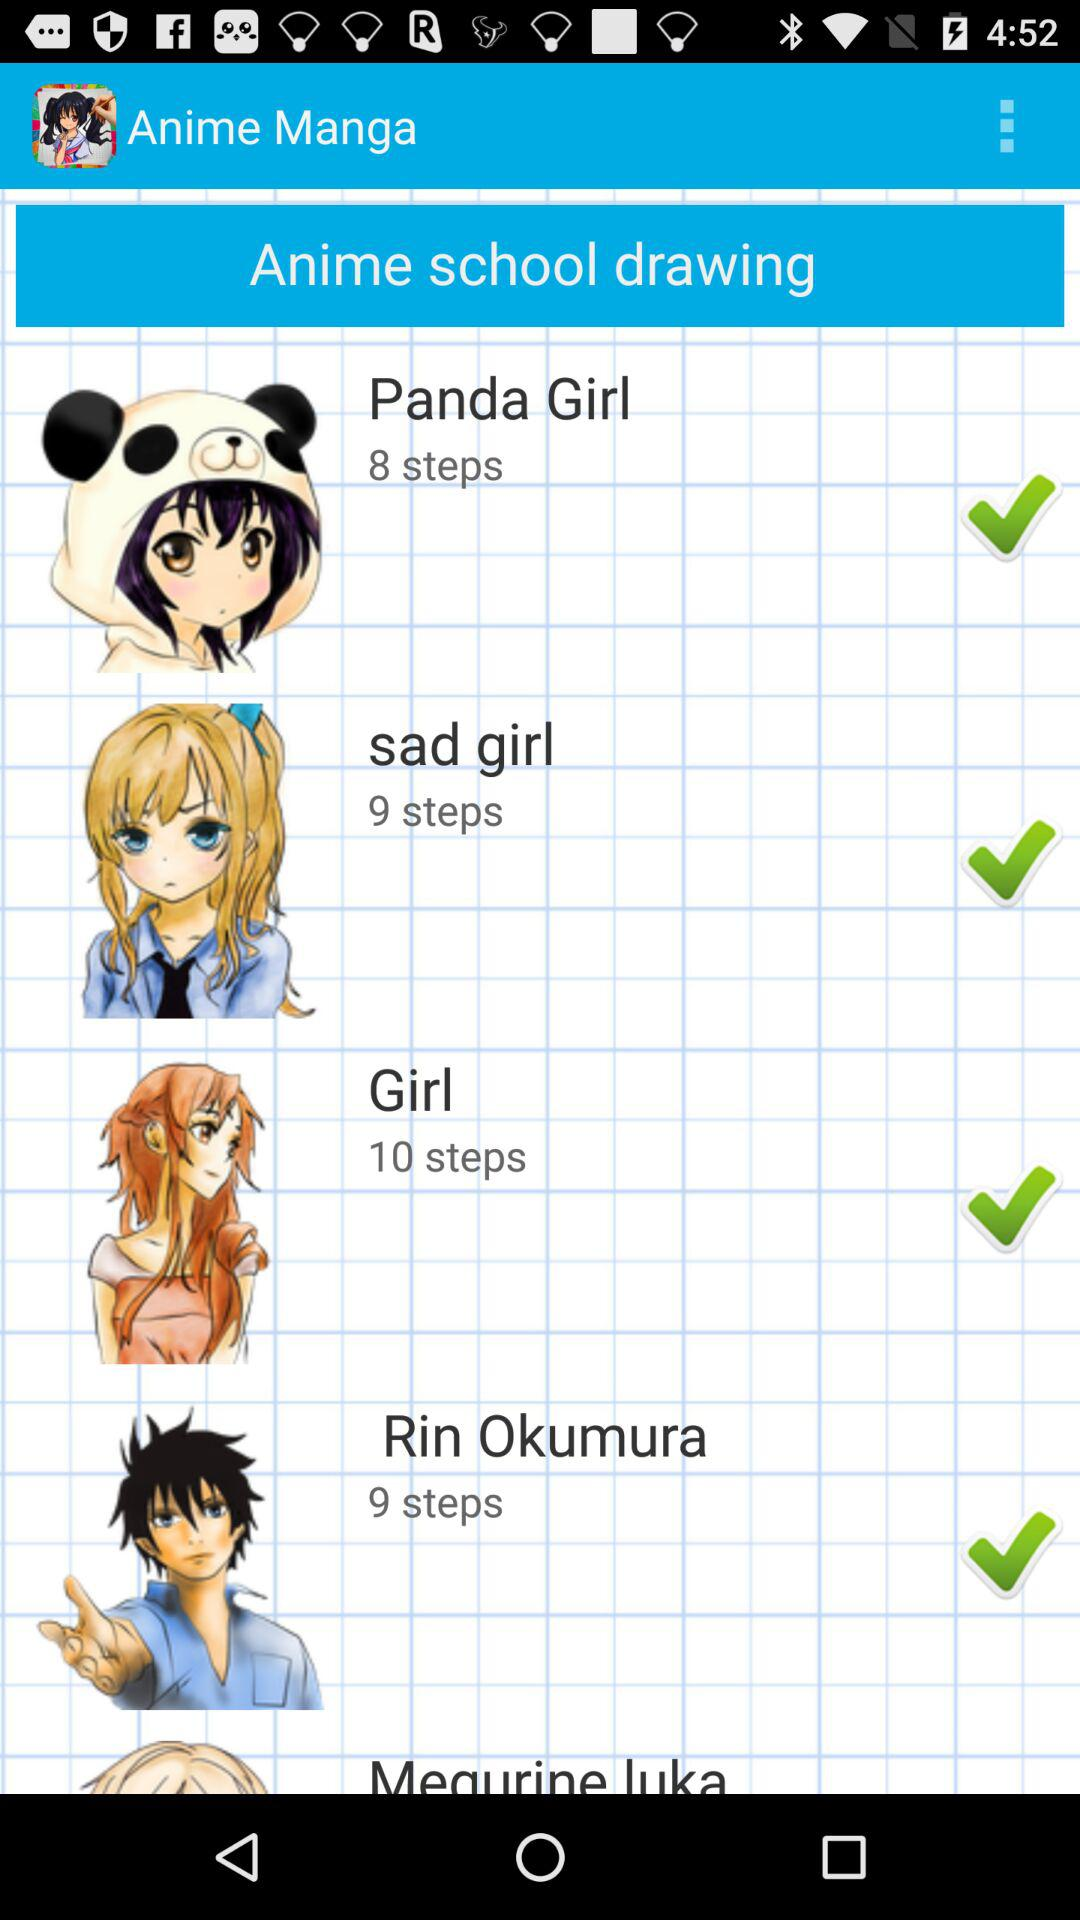How many more steps are needed to draw Rin Okumura than Panda Girl?
Answer the question using a single word or phrase. 1 